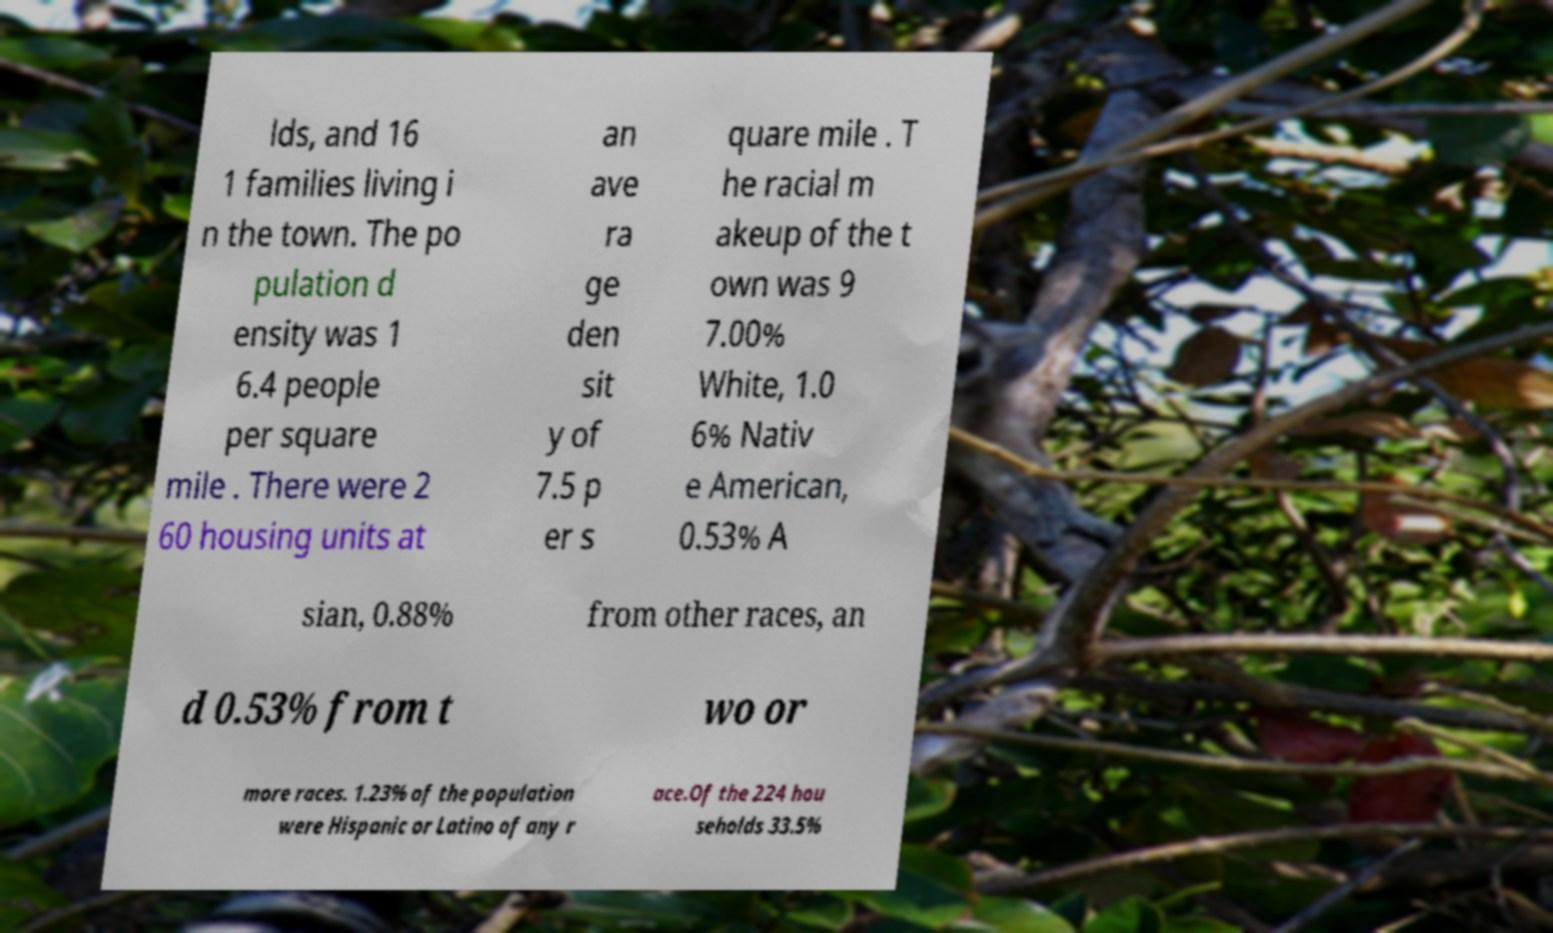For documentation purposes, I need the text within this image transcribed. Could you provide that? lds, and 16 1 families living i n the town. The po pulation d ensity was 1 6.4 people per square mile . There were 2 60 housing units at an ave ra ge den sit y of 7.5 p er s quare mile . T he racial m akeup of the t own was 9 7.00% White, 1.0 6% Nativ e American, 0.53% A sian, 0.88% from other races, an d 0.53% from t wo or more races. 1.23% of the population were Hispanic or Latino of any r ace.Of the 224 hou seholds 33.5% 